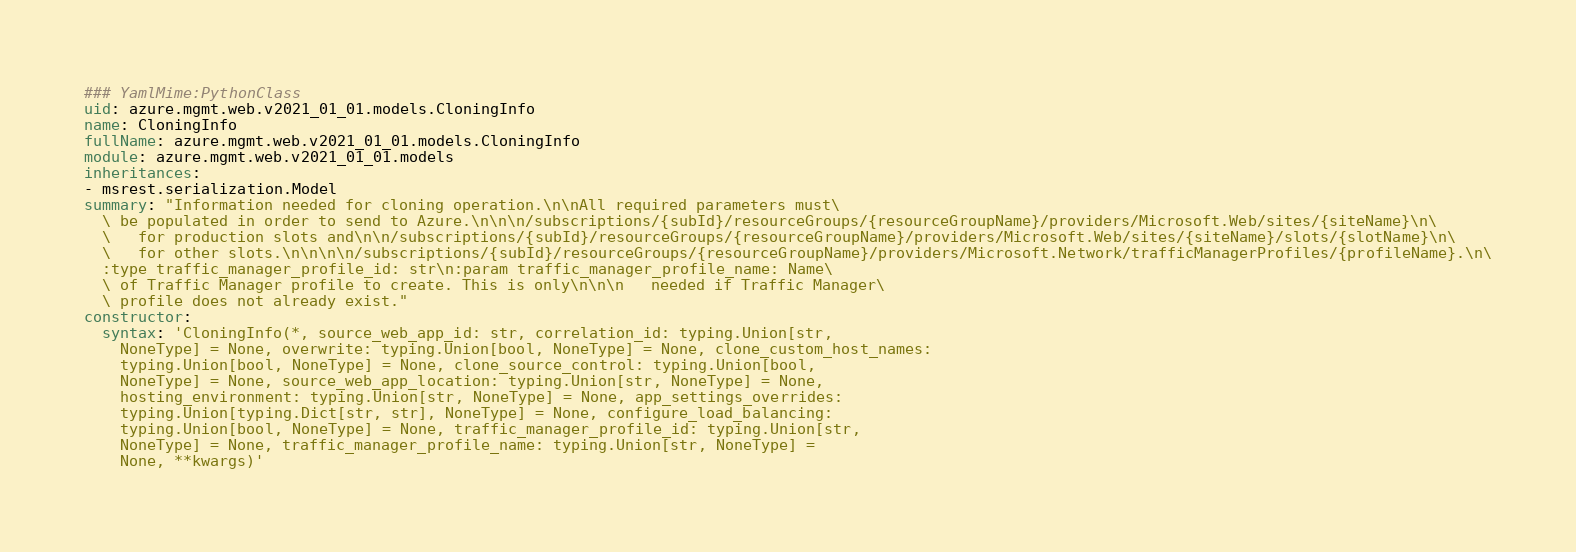<code> <loc_0><loc_0><loc_500><loc_500><_YAML_>### YamlMime:PythonClass
uid: azure.mgmt.web.v2021_01_01.models.CloningInfo
name: CloningInfo
fullName: azure.mgmt.web.v2021_01_01.models.CloningInfo
module: azure.mgmt.web.v2021_01_01.models
inheritances:
- msrest.serialization.Model
summary: "Information needed for cloning operation.\n\nAll required parameters must\
  \ be populated in order to send to Azure.\n\n\n/subscriptions/{subId}/resourceGroups/{resourceGroupName}/providers/Microsoft.Web/sites/{siteName}\n\
  \   for production slots and\n\n/subscriptions/{subId}/resourceGroups/{resourceGroupName}/providers/Microsoft.Web/sites/{siteName}/slots/{slotName}\n\
  \   for other slots.\n\n\n\n/subscriptions/{subId}/resourceGroups/{resourceGroupName}/providers/Microsoft.Network/trafficManagerProfiles/{profileName}.\n\
  :type traffic_manager_profile_id: str\n:param traffic_manager_profile_name: Name\
  \ of Traffic Manager profile to create. This is only\n\n\n   needed if Traffic Manager\
  \ profile does not already exist."
constructor:
  syntax: 'CloningInfo(*, source_web_app_id: str, correlation_id: typing.Union[str,
    NoneType] = None, overwrite: typing.Union[bool, NoneType] = None, clone_custom_host_names:
    typing.Union[bool, NoneType] = None, clone_source_control: typing.Union[bool,
    NoneType] = None, source_web_app_location: typing.Union[str, NoneType] = None,
    hosting_environment: typing.Union[str, NoneType] = None, app_settings_overrides:
    typing.Union[typing.Dict[str, str], NoneType] = None, configure_load_balancing:
    typing.Union[bool, NoneType] = None, traffic_manager_profile_id: typing.Union[str,
    NoneType] = None, traffic_manager_profile_name: typing.Union[str, NoneType] =
    None, **kwargs)'
</code> 